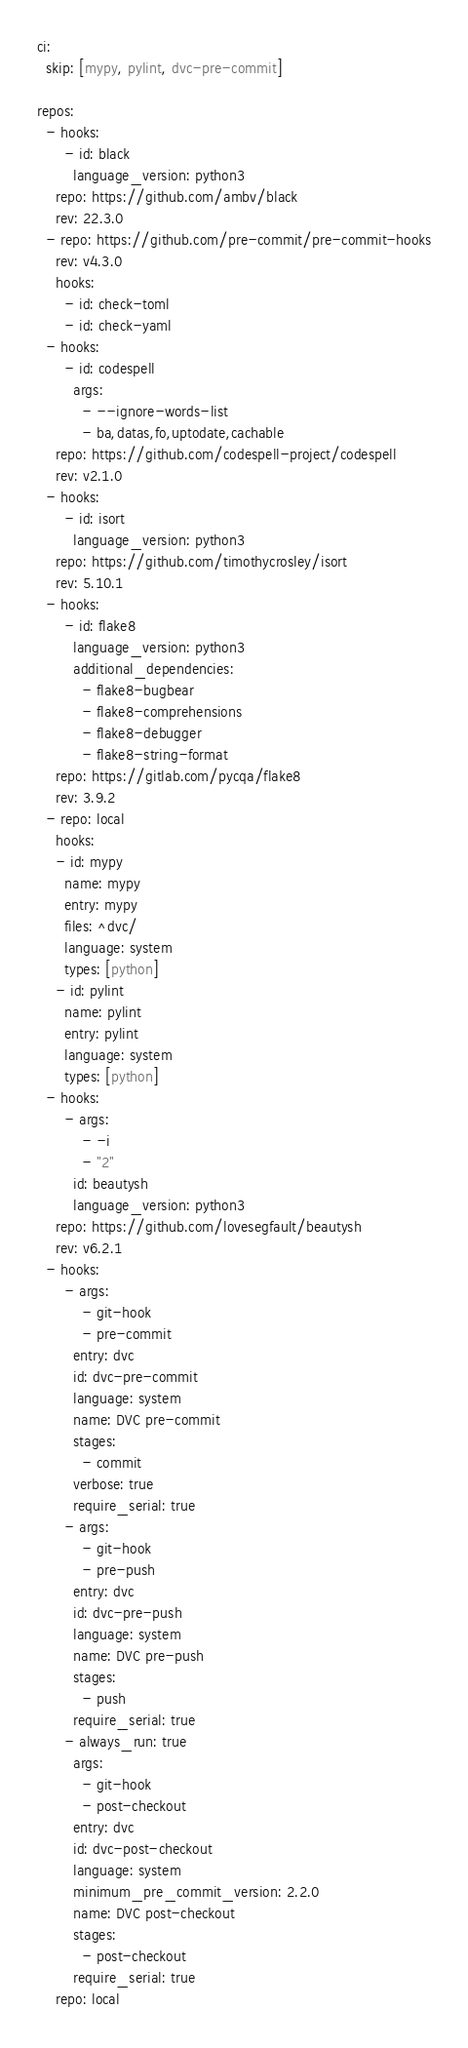<code> <loc_0><loc_0><loc_500><loc_500><_YAML_>ci:
  skip: [mypy, pylint, dvc-pre-commit]

repos:
  - hooks:
      - id: black
        language_version: python3
    repo: https://github.com/ambv/black
    rev: 22.3.0
  - repo: https://github.com/pre-commit/pre-commit-hooks
    rev: v4.3.0
    hooks:
      - id: check-toml
      - id: check-yaml
  - hooks:
      - id: codespell
        args: 
          - --ignore-words-list
          - ba,datas,fo,uptodate,cachable
    repo: https://github.com/codespell-project/codespell
    rev: v2.1.0
  - hooks:
      - id: isort
        language_version: python3
    repo: https://github.com/timothycrosley/isort
    rev: 5.10.1
  - hooks:
      - id: flake8
        language_version: python3
        additional_dependencies:
          - flake8-bugbear
          - flake8-comprehensions
          - flake8-debugger
          - flake8-string-format
    repo: https://gitlab.com/pycqa/flake8
    rev: 3.9.2
  - repo: local
    hooks:
    - id: mypy
      name: mypy
      entry: mypy
      files: ^dvc/
      language: system
      types: [python]
    - id: pylint
      name: pylint
      entry: pylint
      language: system
      types: [python]
  - hooks:
      - args:
          - -i
          - "2"
        id: beautysh
        language_version: python3
    repo: https://github.com/lovesegfault/beautysh
    rev: v6.2.1
  - hooks:
      - args:
          - git-hook
          - pre-commit
        entry: dvc
        id: dvc-pre-commit
        language: system
        name: DVC pre-commit
        stages:
          - commit
        verbose: true
        require_serial: true
      - args:
          - git-hook
          - pre-push
        entry: dvc
        id: dvc-pre-push
        language: system
        name: DVC pre-push
        stages:
          - push
        require_serial: true
      - always_run: true
        args:
          - git-hook
          - post-checkout
        entry: dvc
        id: dvc-post-checkout
        language: system
        minimum_pre_commit_version: 2.2.0
        name: DVC post-checkout
        stages:
          - post-checkout
        require_serial: true
    repo: local
</code> 